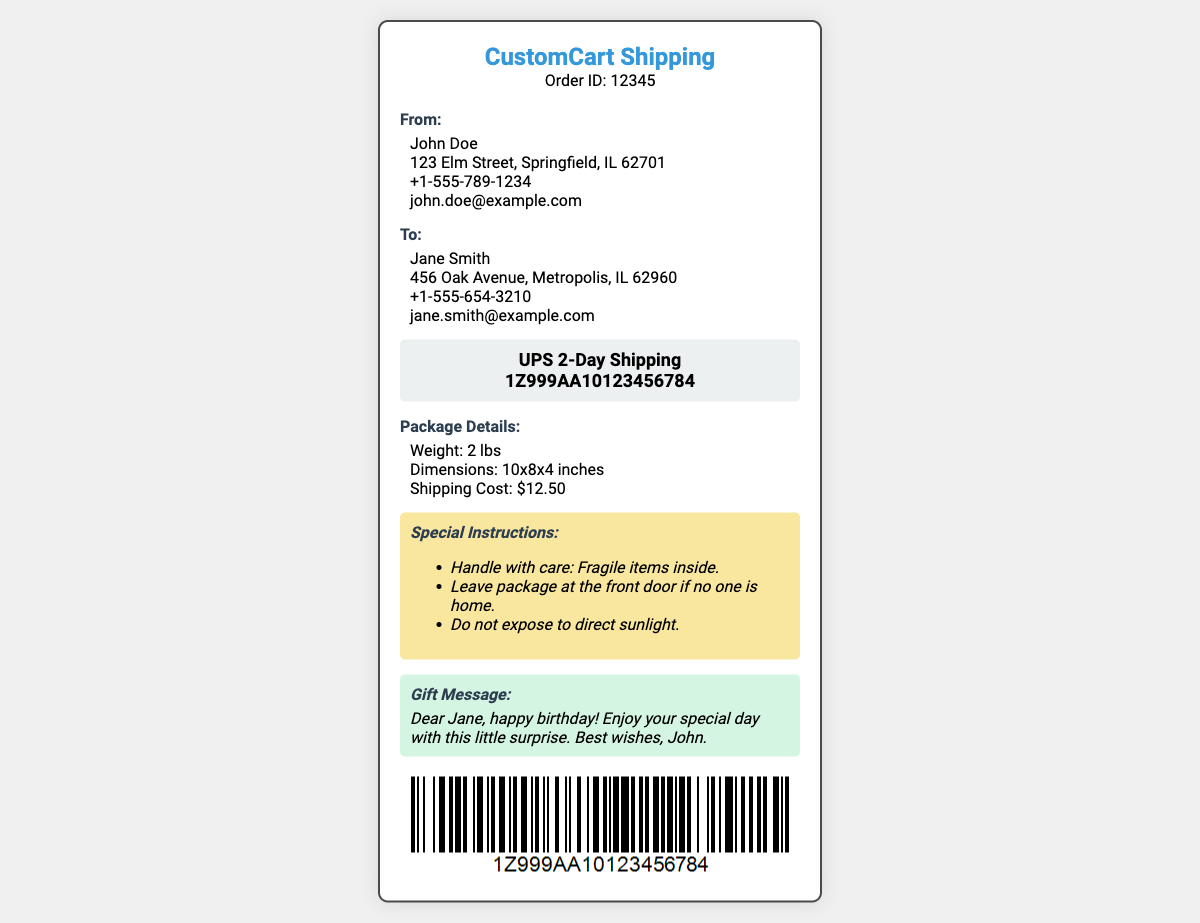What is the order ID? The order ID is displayed in the header of the document under the logo.
Answer: 12345 Who is the sender? The sender's name is located in the "From" section of the document.
Answer: John Doe What is the recipient's address? The recipient's address is listed in the "To" section of the document.
Answer: 456 Oak Avenue, Metropolis, IL 62960 What are the special instructions? Special instructions are listed under the "Special Instructions" section of the document.
Answer: Handle with care: Fragile items inside What is the gift message? The gift message is included in the "Gift Message" section of the document.
Answer: Dear Jane, happy birthday! Enjoy your special day with this little surprise. Best wishes, John 